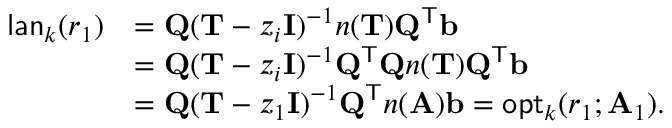<formula> <loc_0><loc_0><loc_500><loc_500>\begin{array} { r l } { l a n _ { k } ( r _ { 1 } ) } & { = Q ( T - z _ { i } I ) ^ { - 1 } n ( T ) Q ^ { T } b } \\ & { = Q ( T - z _ { i } I ) ^ { - 1 } Q ^ { T } Q n ( T ) Q ^ { T } b } \\ & { = Q ( T - z _ { 1 } I ) ^ { - 1 } Q ^ { T } n ( A ) b = o p t _ { k } ( r _ { 1 } ; A _ { 1 } ) . } \end{array}</formula> 